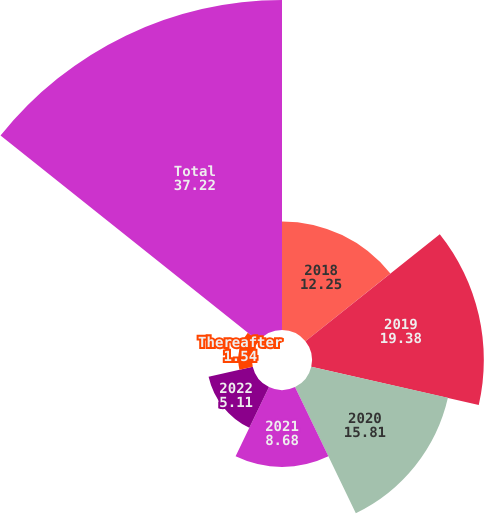Convert chart. <chart><loc_0><loc_0><loc_500><loc_500><pie_chart><fcel>2018<fcel>2019<fcel>2020<fcel>2021<fcel>2022<fcel>Thereafter<fcel>Total<nl><fcel>12.25%<fcel>19.38%<fcel>15.81%<fcel>8.68%<fcel>5.11%<fcel>1.54%<fcel>37.22%<nl></chart> 